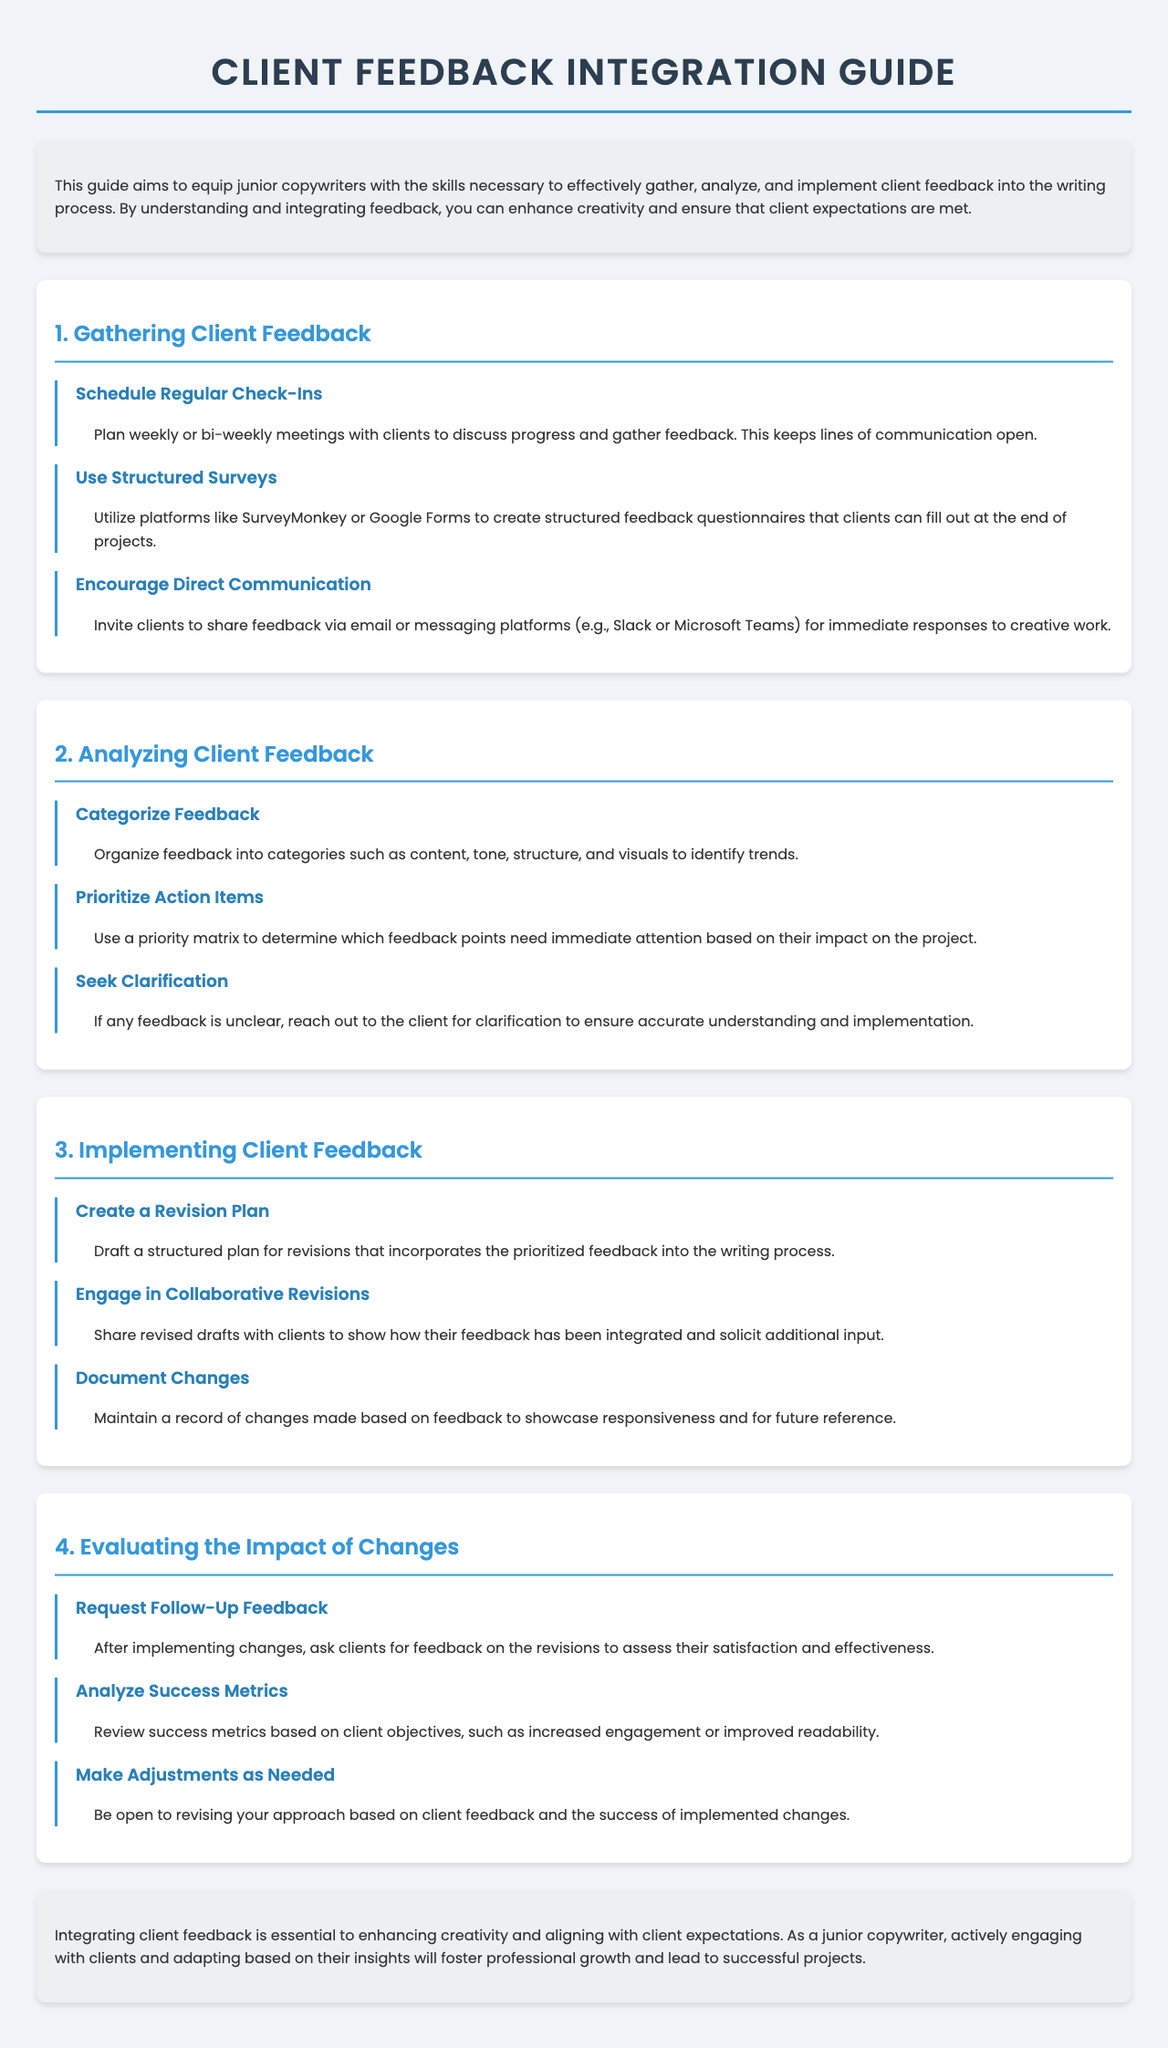what is the title of the document? The title is the main heading of the document, which serves as the subject of the guide.
Answer: Client Feedback Integration Guide how many sections are included in the guide? The number of sections can be counted from the main content of the document.
Answer: Four what is the first step in gathering client feedback? The first step listed indicates an activity to initiate communication with clients for feedback collection.
Answer: Schedule Regular Check-Ins what should be used to categorize feedback? The document mentions a method for organizing feedback into various categories for better understanding.
Answer: Categorize Feedback what does the guide suggest to do after implementing changes? This step follows after making revisions based on client feedback, aimed at obtaining further insights.
Answer: Request Follow-Up Feedback how often should check-ins with clients be scheduled? This frequency is recommended for meetings to keep communication consistent and open.
Answer: Weekly or bi-weekly what is the purpose of creating a revision plan? This step is aimed at facilitating improvements based on collected client feedback.
Answer: Incorporates prioritized feedback what platform is suggested for structured surveys? The document provides examples of tools that can be used for feedback collection through surveys.
Answer: SurveyMonkey or Google Forms what is the final message conveyed in the conclusion? The conclusion summarizes the overall aim of integrating client feedback to enhance the copywriter's approach.
Answer: Essential to enhancing creativity and aligning with client expectations 